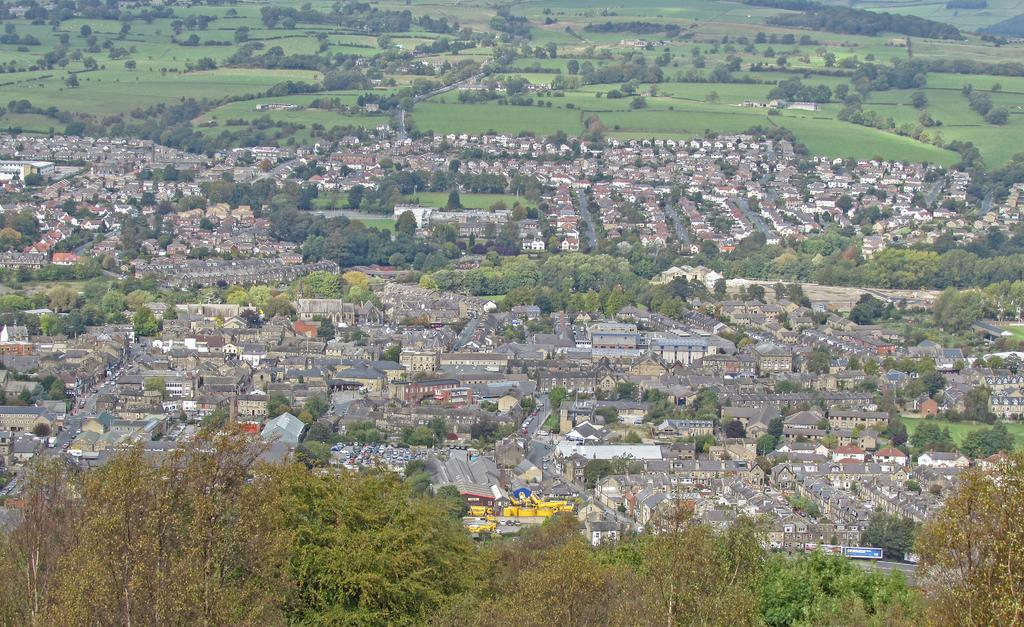What type of structures can be seen in the image? There are buildings in the image. What natural elements are present in the image? There are trees and grass in the image. What type of signs or notices are visible in the image? There are boards with text in the image. What type of transportation is present in the image? There are vehicles in the image. What other objects can be seen in the image besides the ones mentioned? There are other objects in the image. How many fingers can be seen holding the hook in the image? There is no hook or fingers present in the image. What type of shoes are the people wearing in the image? There are no people or shoes visible in the image. 